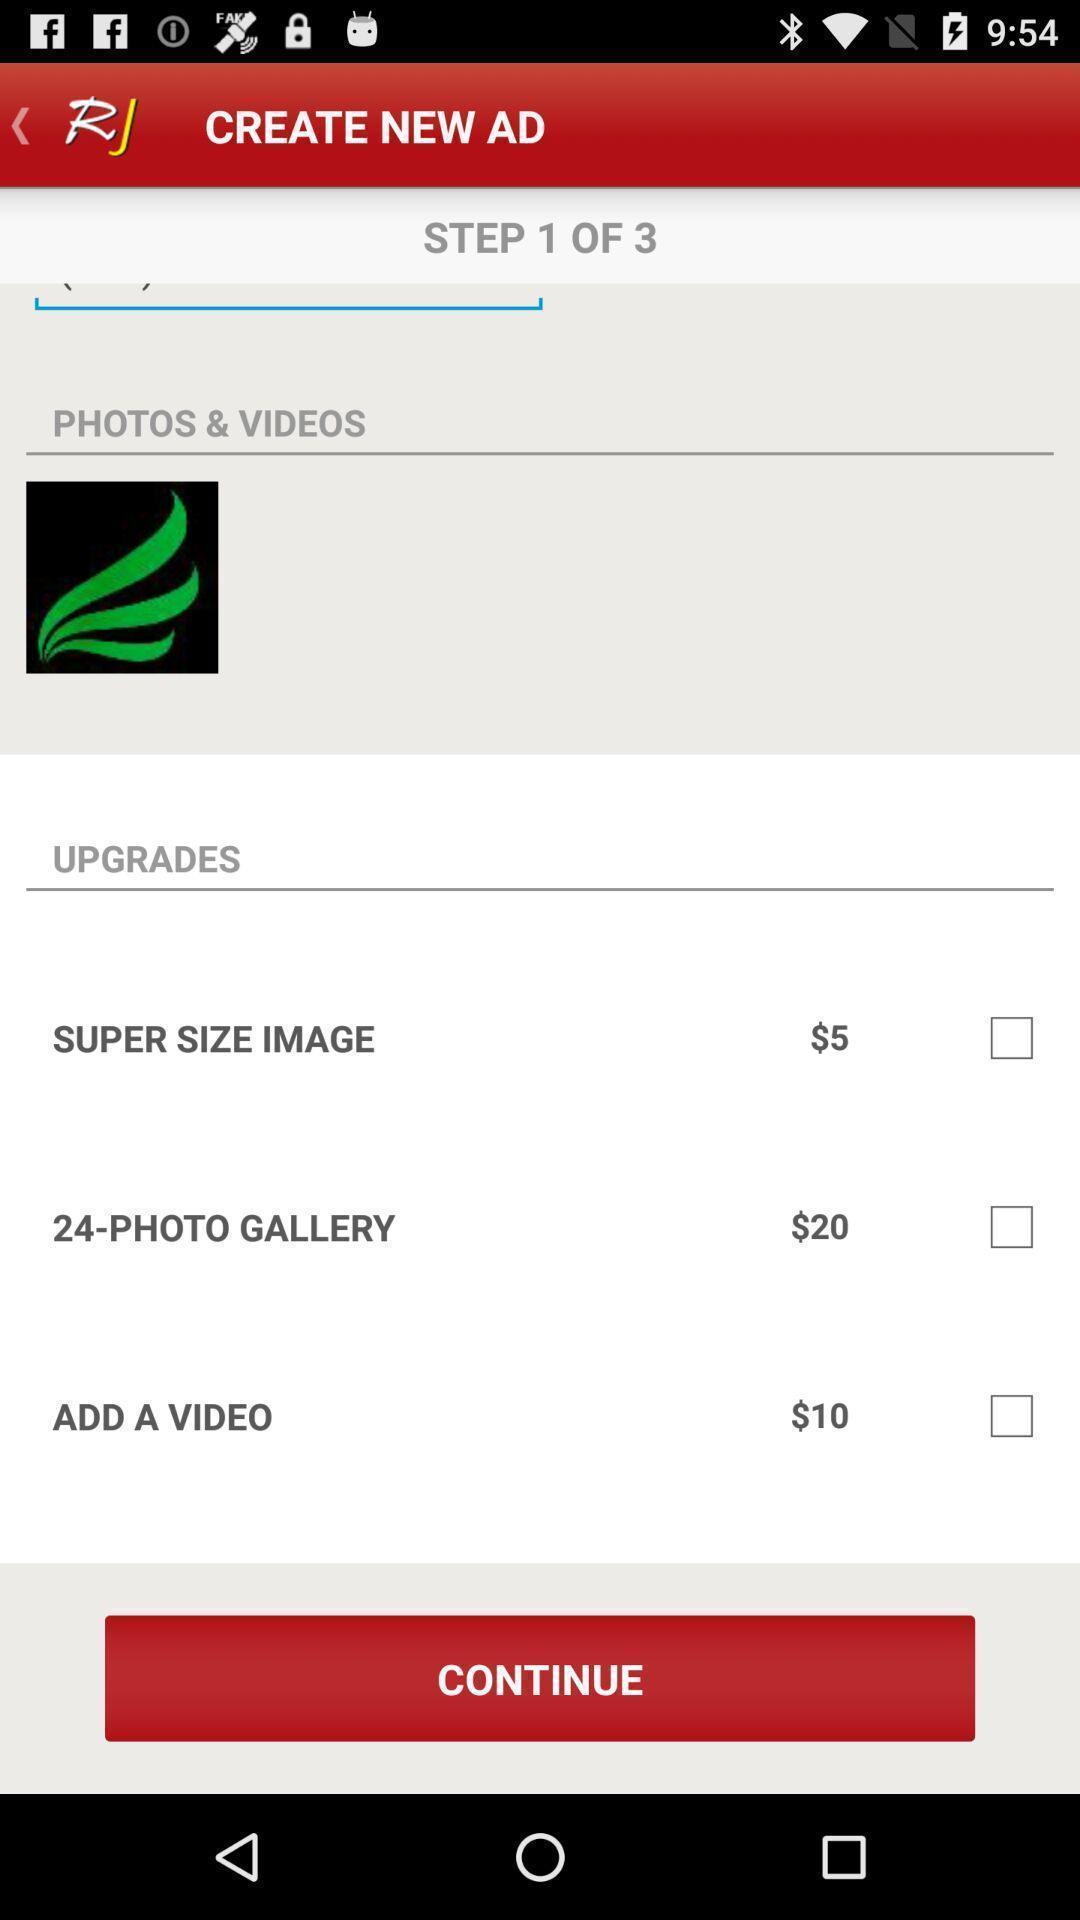What can you discern from this picture? Screen shows create new ad with upgrades. 